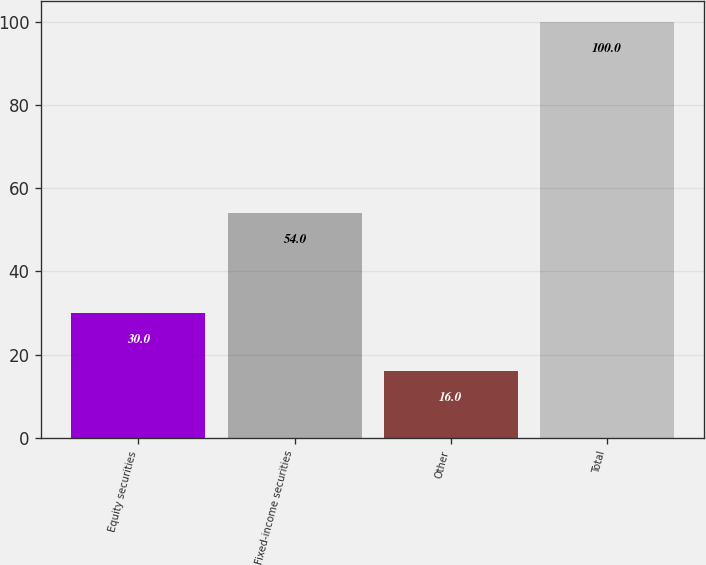Convert chart to OTSL. <chart><loc_0><loc_0><loc_500><loc_500><bar_chart><fcel>Equity securities<fcel>Fixed-income securities<fcel>Other<fcel>Total<nl><fcel>30<fcel>54<fcel>16<fcel>100<nl></chart> 